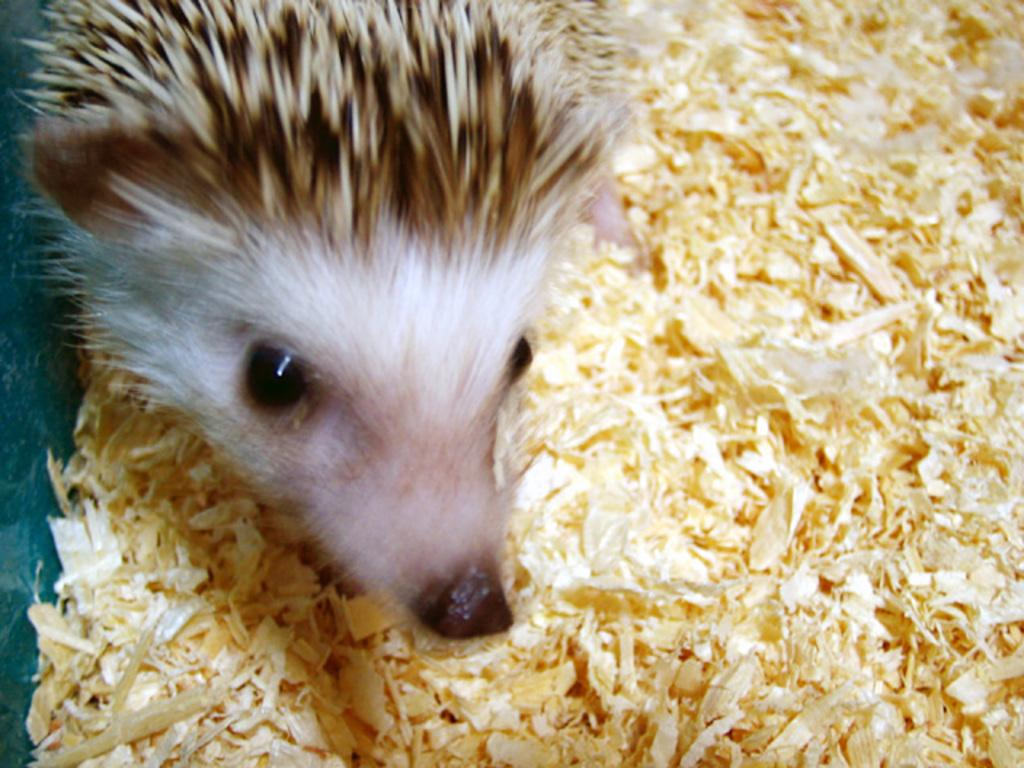What type of animal is present in the image? There is an animal in the image, but the specific type cannot be determined from the provided facts. What material is visible in the image? There is wooden sawdust in the image. How many twigs are being carried by the cattle in the image? There is no cattle or twigs present in the image. What type of monkey can be seen playing with a ball in the image? There is no monkey or ball present in the image. 